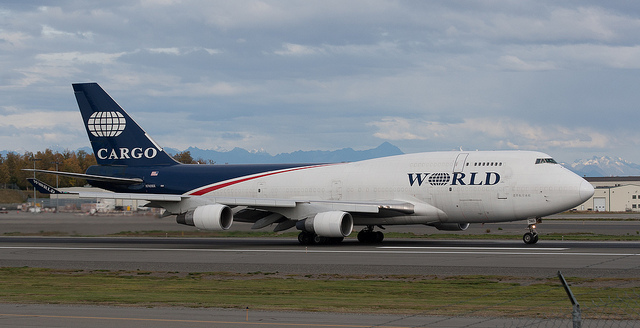<image>Where is the fence? It is not clear where the fence is located. It might be in the background or in the right corner, but no fence could also be shown in the image. Where is the fence? The fence is not shown in the image. 